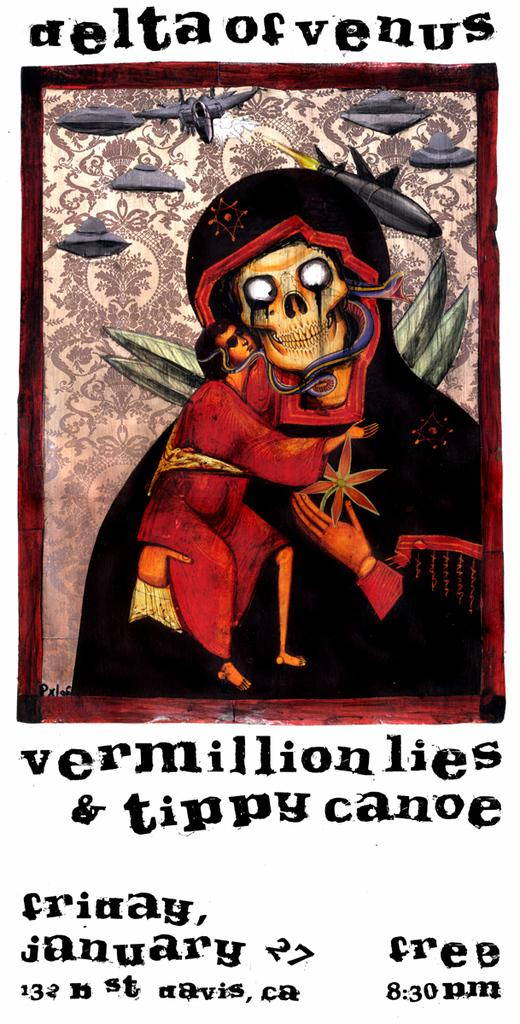Provide a one-sentence caption for the provided image. a skull poster with the words Delta of Venus written above it. 